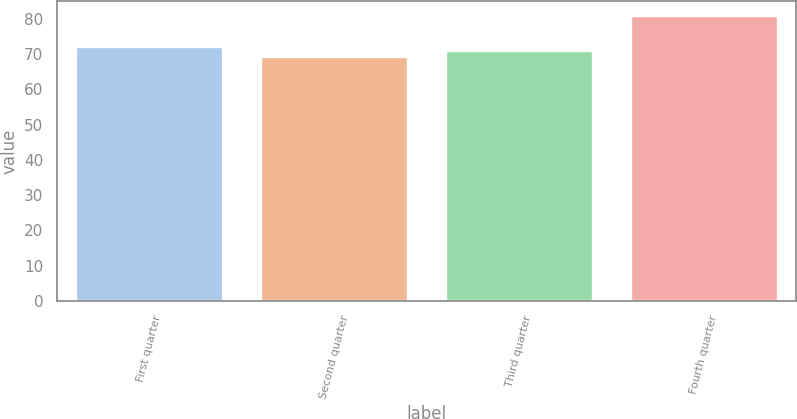Convert chart to OTSL. <chart><loc_0><loc_0><loc_500><loc_500><bar_chart><fcel>First quarter<fcel>Second quarter<fcel>Third quarter<fcel>Fourth quarter<nl><fcel>72.24<fcel>69.48<fcel>71.09<fcel>81<nl></chart> 